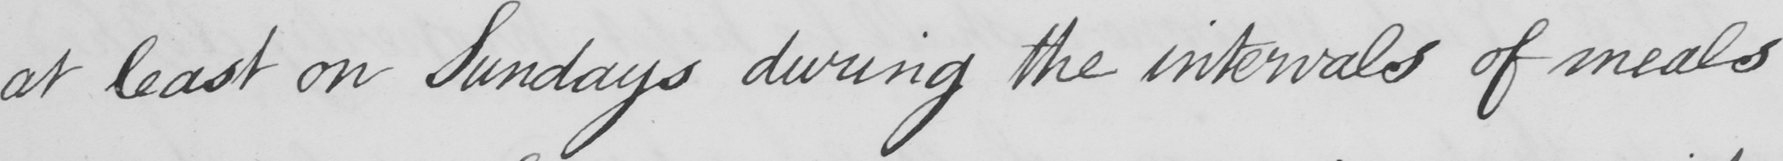What does this handwritten line say? at least on Sundays during the intervals of meals 